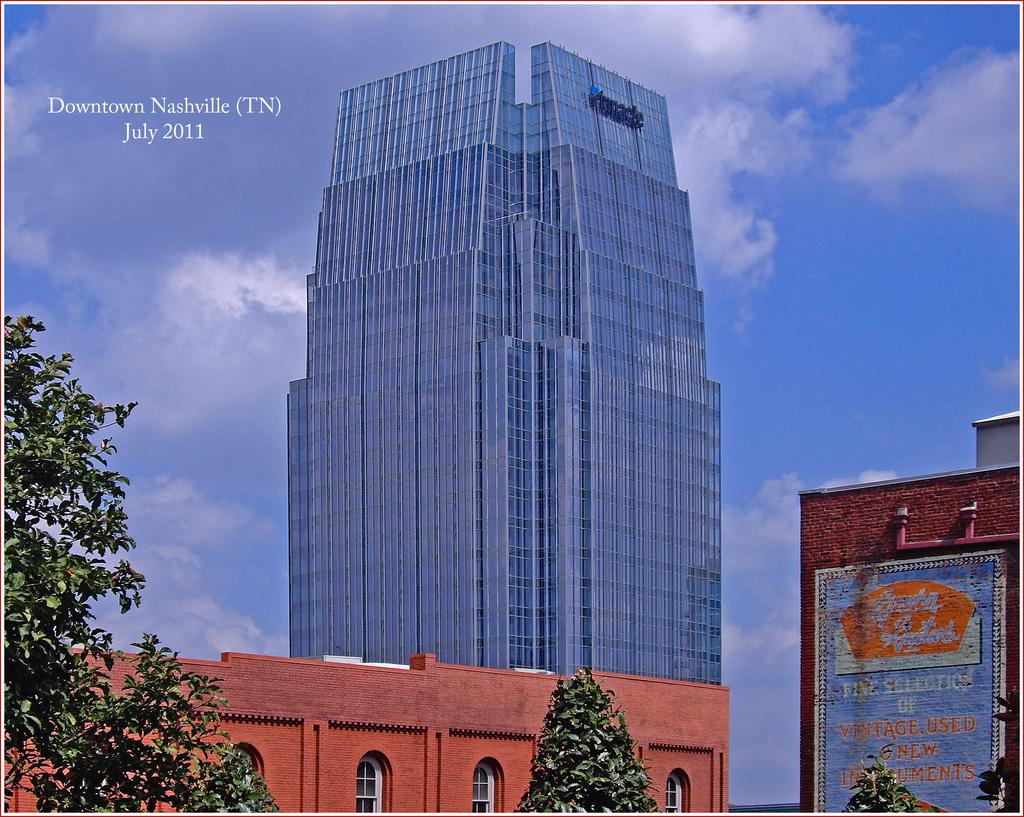What is located in the center of the image? There are buildings in the center of the image. What type of vegetation can be seen in the image? There are trees in the image. What is visible in the background of the image? The sky is visible in the background of the image. What can be observed in the sky in the image? Clouds are present in the background of the image. What type of animal is seen boarding the building in the image? There is no animal or boarding activity present in the image; it features buildings, trees, and a sky with clouds. 